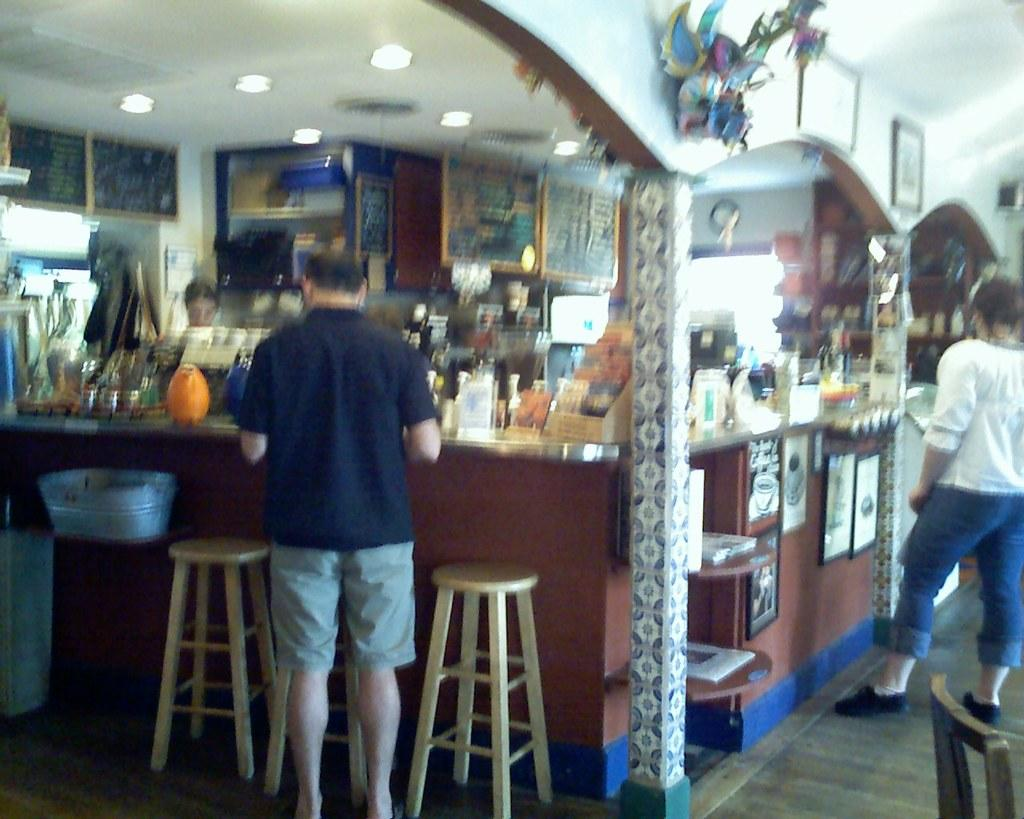What type of establishment is shown in the image? There is a store in the image. What are the people outside the store doing? Two people are standing and watching the items in the store. Can you describe the woman inside the store? There is a woman standing inside the store. What type of furniture is visible in the image? There are chairs visible in the image. What type of stone is being used to build the store in the image? There is no information about the building materials of the store in the image, so it cannot be determined. 